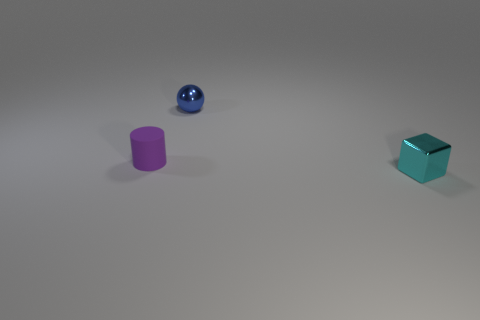Is the shape of the tiny purple rubber object the same as the metallic thing that is behind the tiny cyan metallic thing?
Make the answer very short. No. There is a metal object that is in front of the tiny purple rubber thing; what is its shape?
Provide a short and direct response. Cube. Is the small cyan thing the same shape as the small purple object?
Ensure brevity in your answer.  No. Is the size of the shiny object that is in front of the blue sphere the same as the matte cylinder?
Provide a short and direct response. Yes. There is a thing that is in front of the blue metal thing and to the left of the tiny block; what is its size?
Ensure brevity in your answer.  Small. What number of tiny blocks have the same color as the small rubber cylinder?
Offer a terse response. 0. Are there an equal number of blue spheres left of the matte thing and big gray metallic cylinders?
Your response must be concise. Yes. The small matte cylinder has what color?
Your answer should be very brief. Purple. What is the size of the cyan block that is made of the same material as the small sphere?
Provide a short and direct response. Small. There is another thing that is made of the same material as the cyan object; what is its color?
Offer a terse response. Blue. 